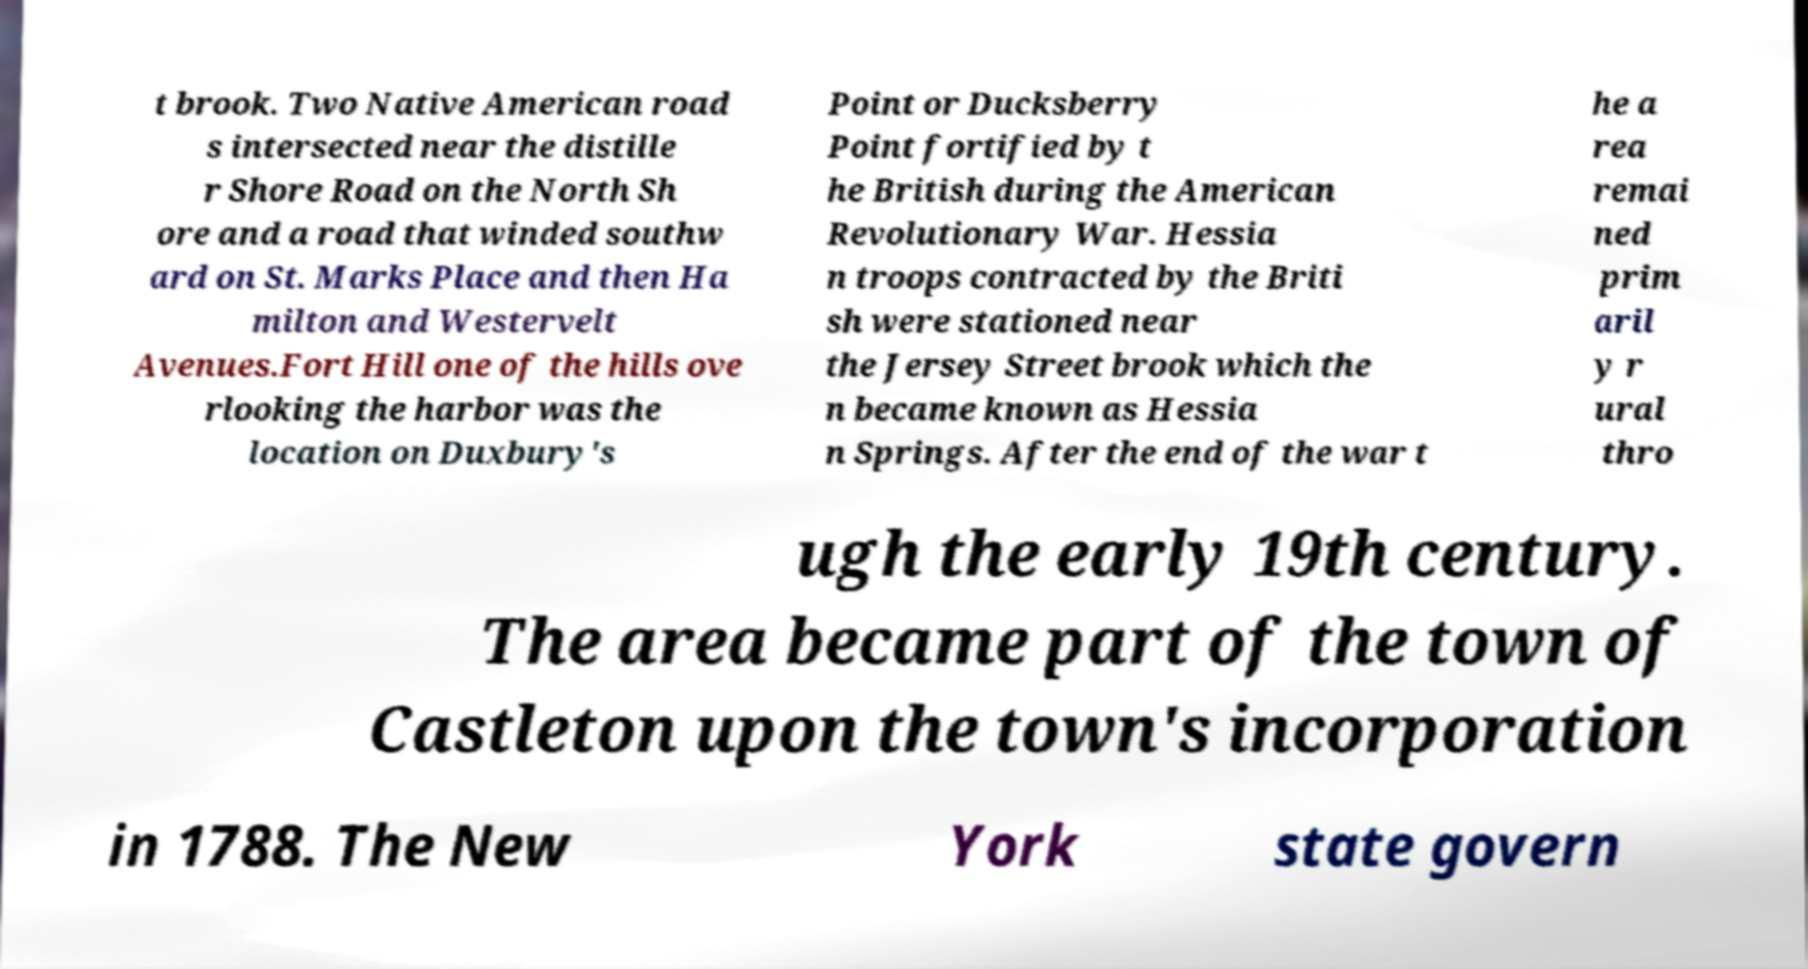Could you extract and type out the text from this image? t brook. Two Native American road s intersected near the distille r Shore Road on the North Sh ore and a road that winded southw ard on St. Marks Place and then Ha milton and Westervelt Avenues.Fort Hill one of the hills ove rlooking the harbor was the location on Duxbury's Point or Ducksberry Point fortified by t he British during the American Revolutionary War. Hessia n troops contracted by the Briti sh were stationed near the Jersey Street brook which the n became known as Hessia n Springs. After the end of the war t he a rea remai ned prim aril y r ural thro ugh the early 19th century. The area became part of the town of Castleton upon the town's incorporation in 1788. The New York state govern 